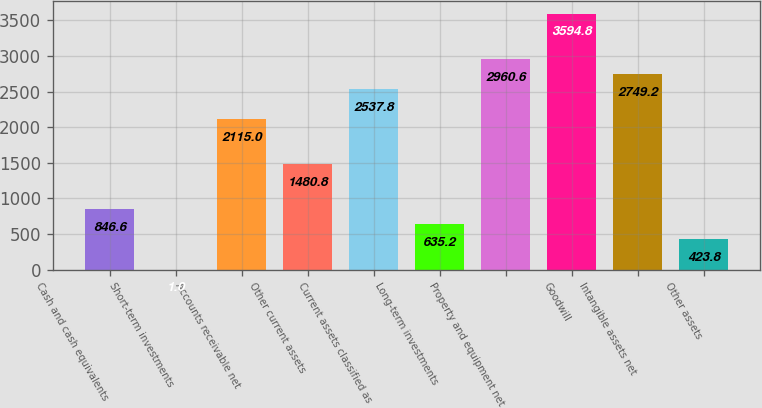Convert chart to OTSL. <chart><loc_0><loc_0><loc_500><loc_500><bar_chart><fcel>Cash and cash equivalents<fcel>Short-term investments<fcel>Accounts receivable net<fcel>Other current assets<fcel>Current assets classified as<fcel>Long-term investments<fcel>Property and equipment net<fcel>Goodwill<fcel>Intangible assets net<fcel>Other assets<nl><fcel>846.6<fcel>1<fcel>2115<fcel>1480.8<fcel>2537.8<fcel>635.2<fcel>2960.6<fcel>3594.8<fcel>2749.2<fcel>423.8<nl></chart> 